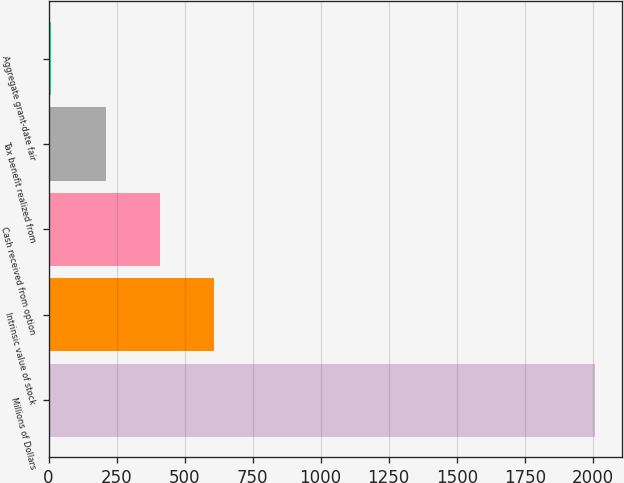Convert chart to OTSL. <chart><loc_0><loc_0><loc_500><loc_500><bar_chart><fcel>Millions of Dollars<fcel>Intrinsic value of stock<fcel>Cash received from option<fcel>Tax benefit realized from<fcel>Aggregate grant-date fair<nl><fcel>2007<fcel>609.8<fcel>410.2<fcel>210.6<fcel>11<nl></chart> 